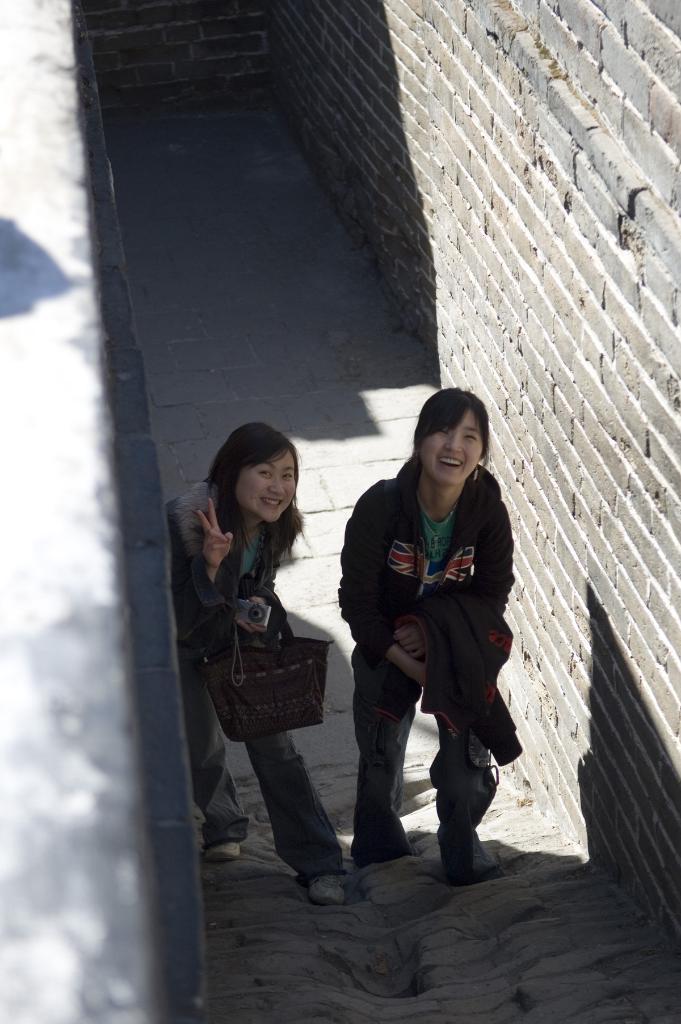How would you summarize this image in a sentence or two? There are two women standing and smiling and she is holding a bag and camera. We can see wall. 